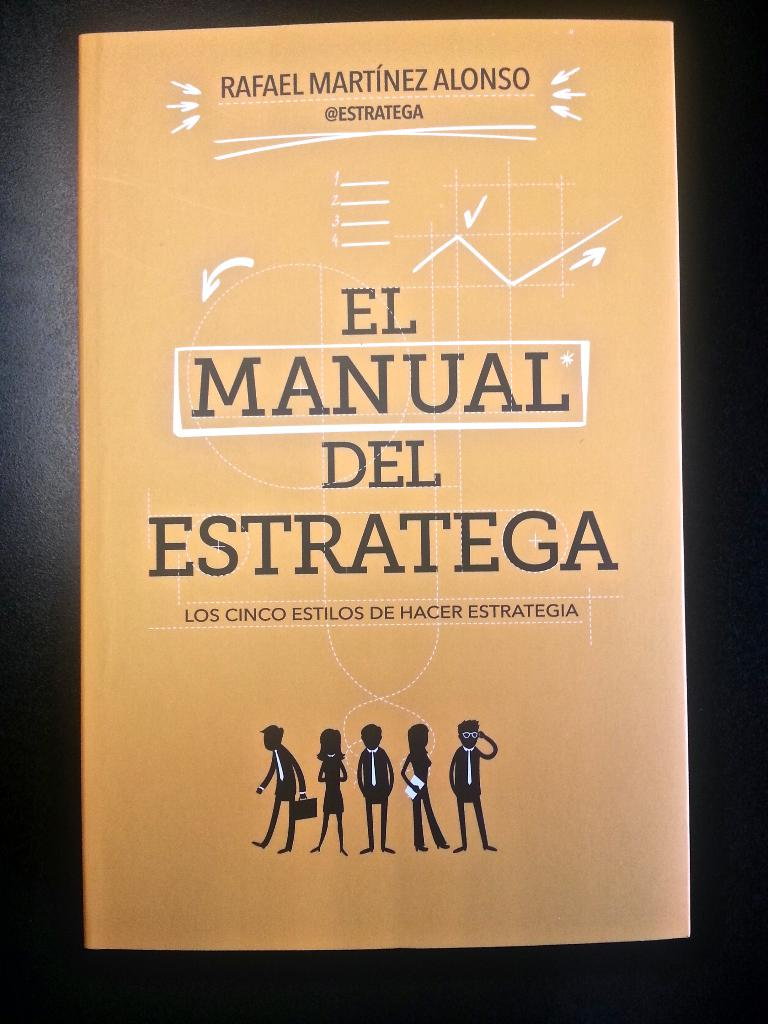Can you tell me more about the author mentioned on this book cover? Rafael Martínez Alonso, whose name appears prominently on the book cover, is likely an expert in strategic methods and possibly an influencer in the field of business strategy. The author's visible Twitter handle suggests he engages with a wider audience through social media, possibly sharing insights, updates, and discussions related to strategic thinking and business innovations. 